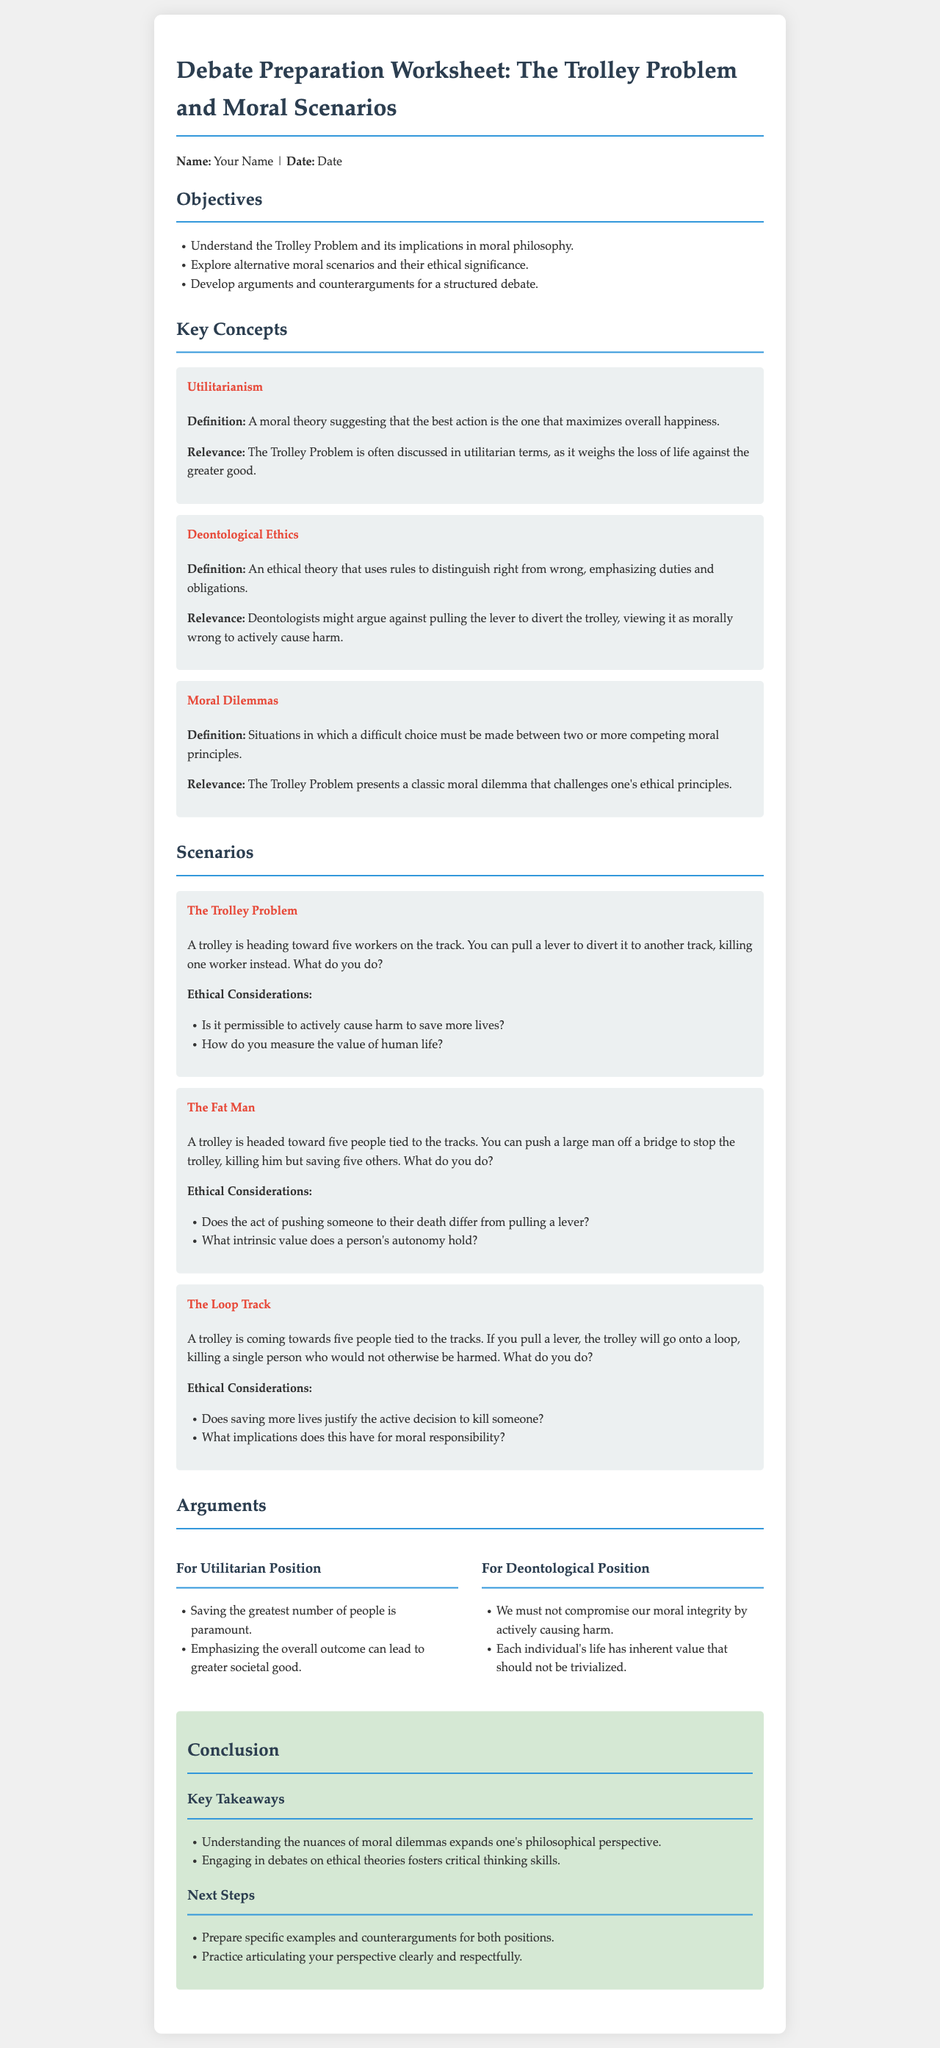What is the title of the worksheet? The title of the worksheet is presented at the top of the document.
Answer: Debate Preparation Worksheet: The Trolley Problem and Moral Scenarios What is the first objective listed? The first objective is the first item in the objectives section.
Answer: Understand the Trolley Problem and its implications in moral philosophy What ethical theory emphasizes duties and obligations? This information can be found in the Key Concepts section.
Answer: Deontological Ethics How many scenarios are presented in the document? The document lists the total number of scenarios in the Scenarios section.
Answer: Three What ethical consideration is associated with The Fat Man scenario? This consideration is listed under the Ethical Considerations of that scenario.
Answer: Does the act of pushing someone to their death differ from pulling a lever? What is one argument for the Utilitarian Position? This argument can be found in the Arguments section.
Answer: Saving the greatest number of people is paramount What are the key takeaways listed in the conclusion section? The key takeaways are summarized in bullet points in the conclusion section.
Answer: Understanding the nuances of moral dilemmas expands one's philosophical perspective What is suggested as a next step in the conclusion? This suggestion is the first item in the Next Steps section.
Answer: Prepare specific examples and counterarguments for both positions 